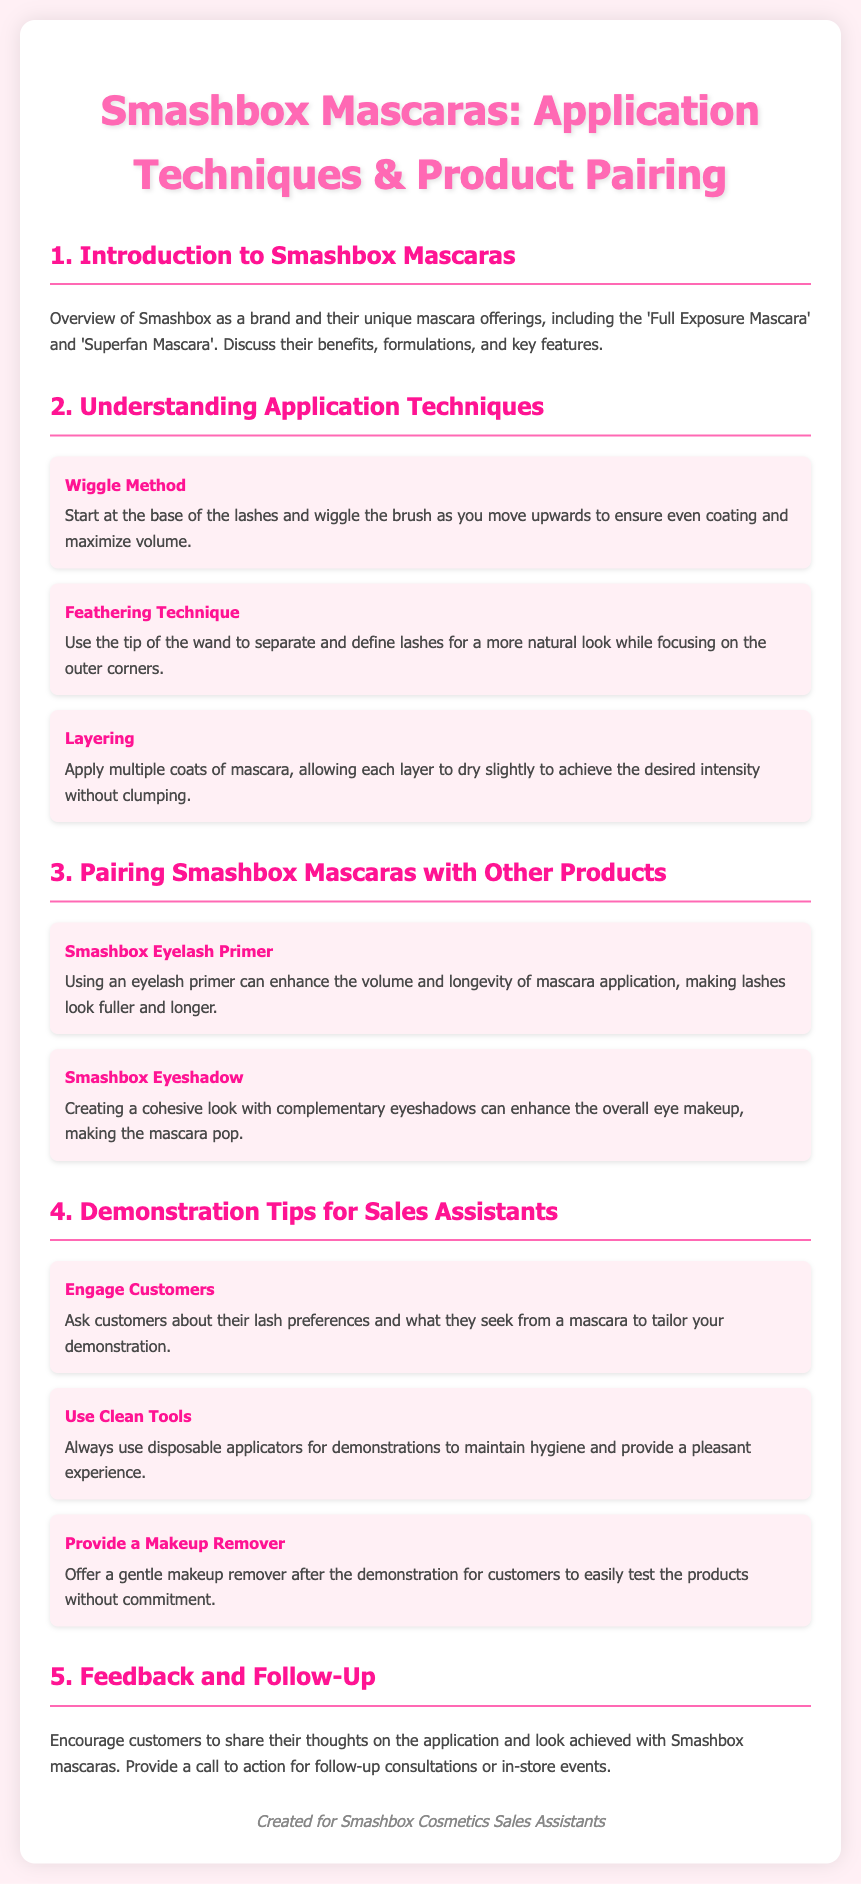What are the two main mascaras offered by Smashbox? The document mentions 'Full Exposure Mascara' and 'Superfan Mascara' as the unique mascara offerings from Smashbox.
Answer: Full Exposure Mascara, Superfan Mascara What is the Wiggle Method used for? The Wiggle Method is a technique that ensures even coating and maximizes volume by starting at the base of the lashes and wiggling the brush upwards.
Answer: To ensure even coating and maximize volume What is the benefit of using Smashbox Eyelash Primer? The document states that using an eyelash primer can enhance the volume and longevity of mascara application, making lashes look fuller and longer.
Answer: Enhance volume and longevity How many application techniques are listed in the document? The document lists three application techniques, which are the Wiggle Method, Feathering Technique, and Layering.
Answer: Three What should sales assistants do to maintain hygiene during demonstrations? The document advises that sales assistants should always use disposable applicators during demonstrations to maintain hygiene.
Answer: Use disposable applicators What should you offer customers after demonstrating Smashbox mascaras? The document suggests providing a gentle makeup remover for customers to test the products without commitment.
Answer: Gentle makeup remover 